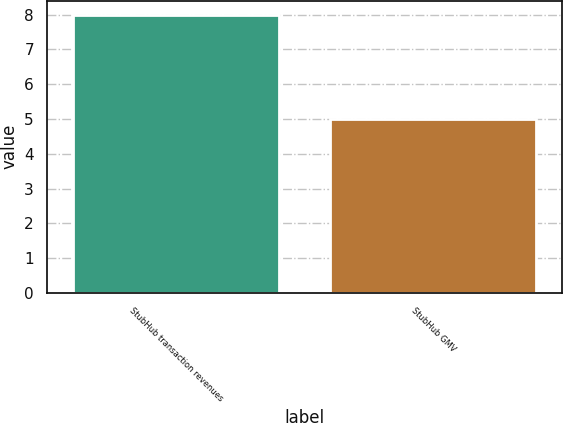Convert chart. <chart><loc_0><loc_0><loc_500><loc_500><bar_chart><fcel>StubHub transaction revenues<fcel>StubHub GMV<nl><fcel>8<fcel>5<nl></chart> 